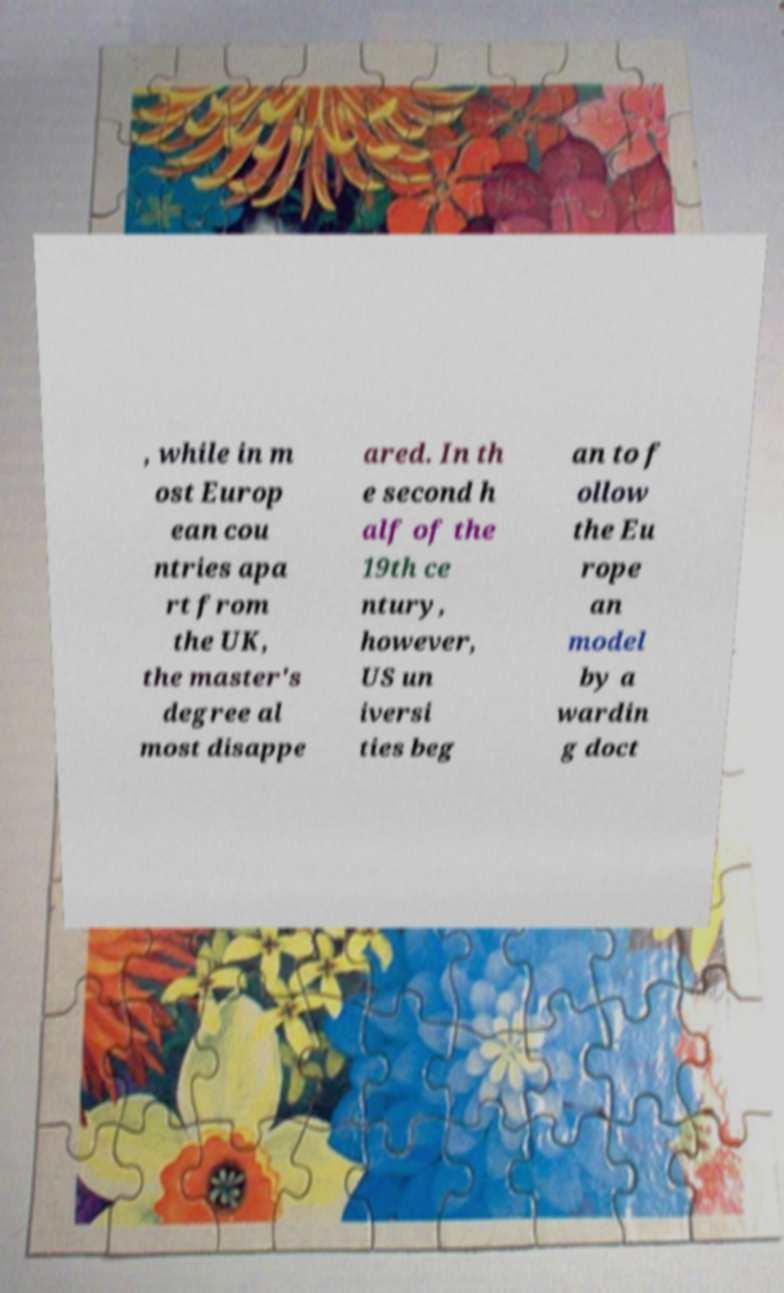There's text embedded in this image that I need extracted. Can you transcribe it verbatim? , while in m ost Europ ean cou ntries apa rt from the UK, the master's degree al most disappe ared. In th e second h alf of the 19th ce ntury, however, US un iversi ties beg an to f ollow the Eu rope an model by a wardin g doct 